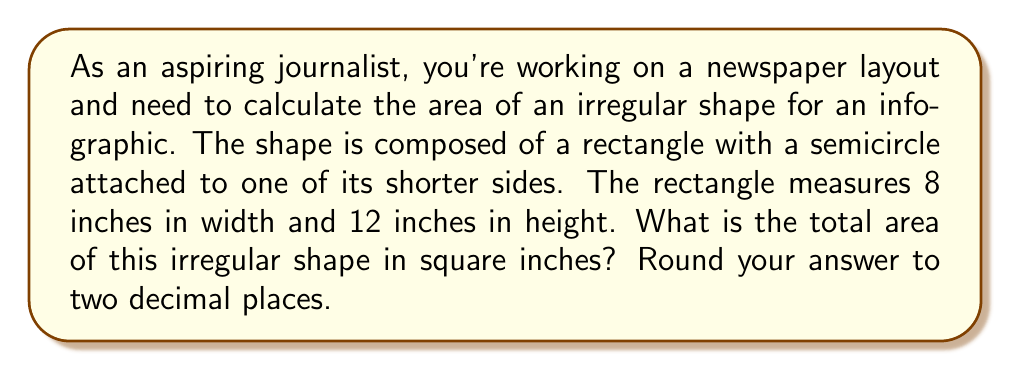Could you help me with this problem? To solve this problem, we need to break it down into two parts: the area of the rectangle and the area of the semicircle. Then, we'll add these areas together.

1. Calculate the area of the rectangle:
   $$A_{rectangle} = width \times height$$
   $$A_{rectangle} = 8 \times 12 = 96 \text{ sq inches}$$

2. Calculate the area of the semicircle:
   The diameter of the semicircle is equal to the width of the rectangle, which is 8 inches.
   The radius is half of this, so $r = 4$ inches.
   
   Area of a full circle: $$A_{circle} = \pi r^2$$
   Area of a semicircle: $$A_{semicircle} = \frac{1}{2} \pi r^2$$
   
   $$A_{semicircle} = \frac{1}{2} \times \pi \times 4^2$$
   $$A_{semicircle} = 8\pi \approx 25.13 \text{ sq inches}$$

3. Calculate the total area by adding the areas of the rectangle and semicircle:
   $$A_{total} = A_{rectangle} + A_{semicircle}$$
   $$A_{total} = 96 + 25.13 = 121.13 \text{ sq inches}$$

4. Round the answer to two decimal places:
   $$A_{total} \approx 121.13 \text{ sq inches}$$

[asy]
unitsize(0.25 inch);
fill((0,0)--(8,0)--(8,12)--(0,12)--cycle, lightgray);
fill(arc((4,12), 4, 0, 180)--cycle, lightgray);
draw((0,0)--(8,0)--(8,12)--(0,12)--cycle);
draw(arc((4,12), 4, 0, 180));
label("8", (4,0), S);
label("12", (0,6), W);
[/asy]
Answer: 121.13 sq inches 